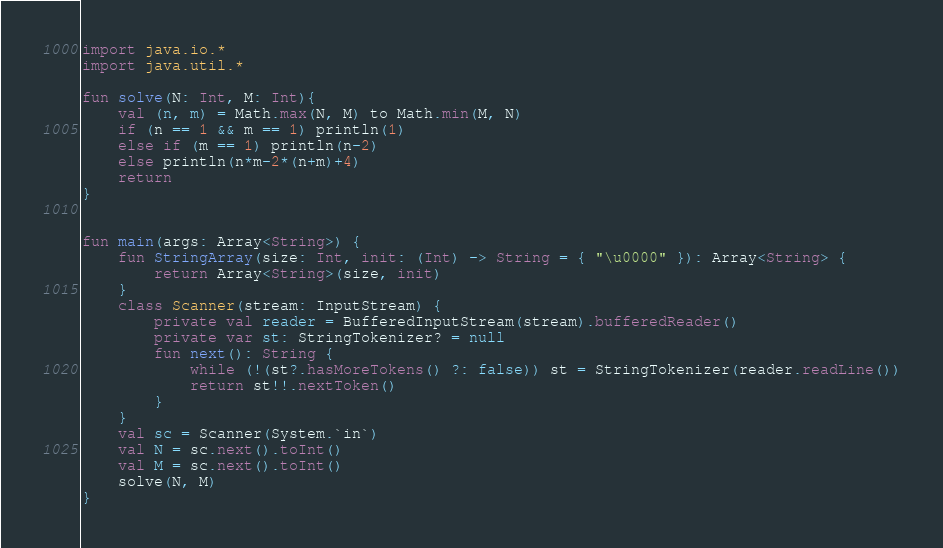Convert code to text. <code><loc_0><loc_0><loc_500><loc_500><_Kotlin_>import java.io.*
import java.util.*

fun solve(N: Int, M: Int){
    val (n, m) = Math.max(N, M) to Math.min(M, N)
    if (n == 1 && m == 1) println(1)
    else if (m == 1) println(n-2)
    else println(n*m-2*(n+m)+4)
    return
}


fun main(args: Array<String>) {
    fun StringArray(size: Int, init: (Int) -> String = { "\u0000" }): Array<String> {
        return Array<String>(size, init)
    }
    class Scanner(stream: InputStream) {
        private val reader = BufferedInputStream(stream).bufferedReader()
        private var st: StringTokenizer? = null
        fun next(): String {
            while (!(st?.hasMoreTokens() ?: false)) st = StringTokenizer(reader.readLine())
            return st!!.nextToken()
        }
    }
    val sc = Scanner(System.`in`)
    val N = sc.next().toInt()
    val M = sc.next().toInt()
    solve(N, M)
}

</code> 